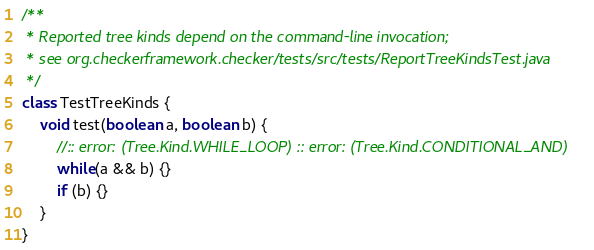<code> <loc_0><loc_0><loc_500><loc_500><_Java_>/**
 * Reported tree kinds depend on the command-line invocation;
 * see org.checkerframework.checker/tests/src/tests/ReportTreeKindsTest.java
 */
class TestTreeKinds {
    void test(boolean a, boolean b) {
        //:: error: (Tree.Kind.WHILE_LOOP) :: error: (Tree.Kind.CONDITIONAL_AND)
        while(a && b) {}
        if (b) {}
    }
}</code> 